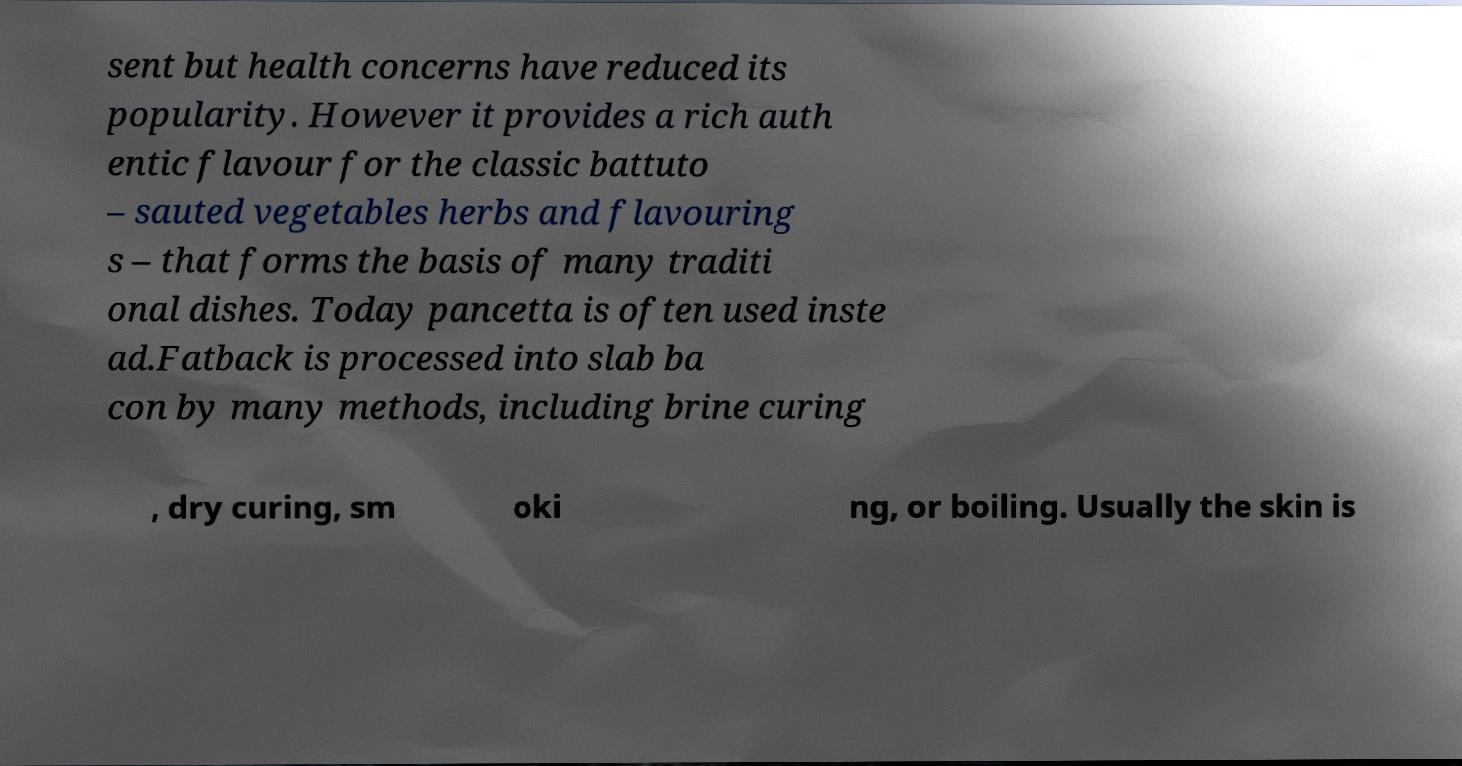What messages or text are displayed in this image? I need them in a readable, typed format. sent but health concerns have reduced its popularity. However it provides a rich auth entic flavour for the classic battuto – sauted vegetables herbs and flavouring s – that forms the basis of many traditi onal dishes. Today pancetta is often used inste ad.Fatback is processed into slab ba con by many methods, including brine curing , dry curing, sm oki ng, or boiling. Usually the skin is 